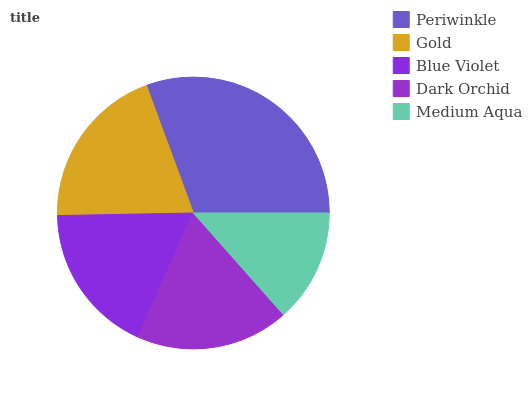Is Medium Aqua the minimum?
Answer yes or no. Yes. Is Periwinkle the maximum?
Answer yes or no. Yes. Is Gold the minimum?
Answer yes or no. No. Is Gold the maximum?
Answer yes or no. No. Is Periwinkle greater than Gold?
Answer yes or no. Yes. Is Gold less than Periwinkle?
Answer yes or no. Yes. Is Gold greater than Periwinkle?
Answer yes or no. No. Is Periwinkle less than Gold?
Answer yes or no. No. Is Dark Orchid the high median?
Answer yes or no. Yes. Is Dark Orchid the low median?
Answer yes or no. Yes. Is Gold the high median?
Answer yes or no. No. Is Periwinkle the low median?
Answer yes or no. No. 